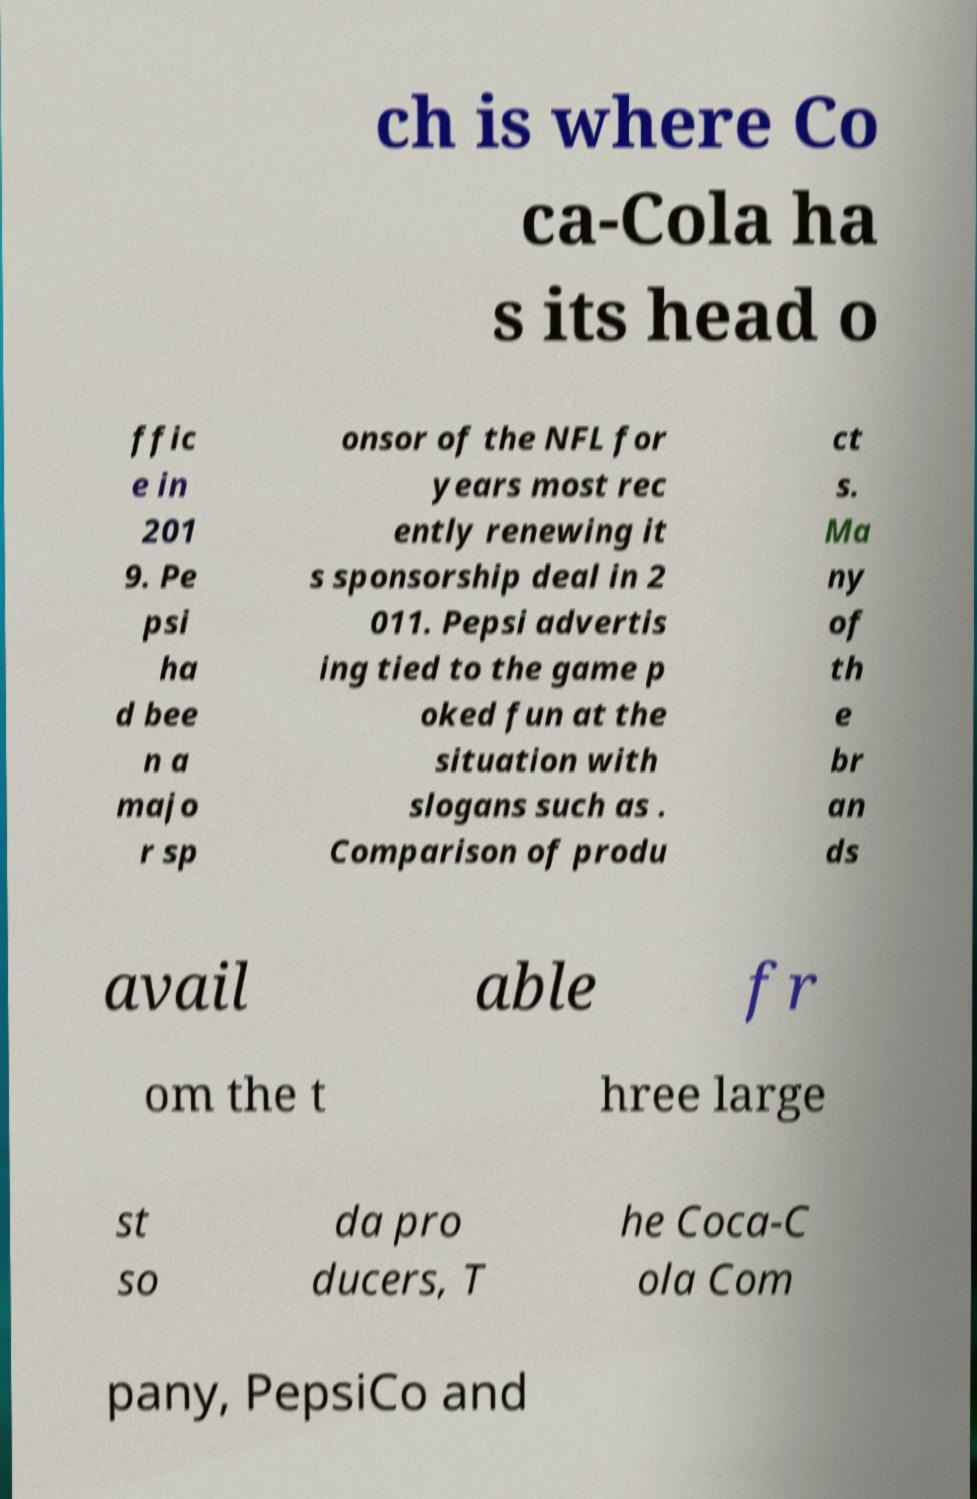What messages or text are displayed in this image? I need them in a readable, typed format. ch is where Co ca-Cola ha s its head o ffic e in 201 9. Pe psi ha d bee n a majo r sp onsor of the NFL for years most rec ently renewing it s sponsorship deal in 2 011. Pepsi advertis ing tied to the game p oked fun at the situation with slogans such as . Comparison of produ ct s. Ma ny of th e br an ds avail able fr om the t hree large st so da pro ducers, T he Coca-C ola Com pany, PepsiCo and 